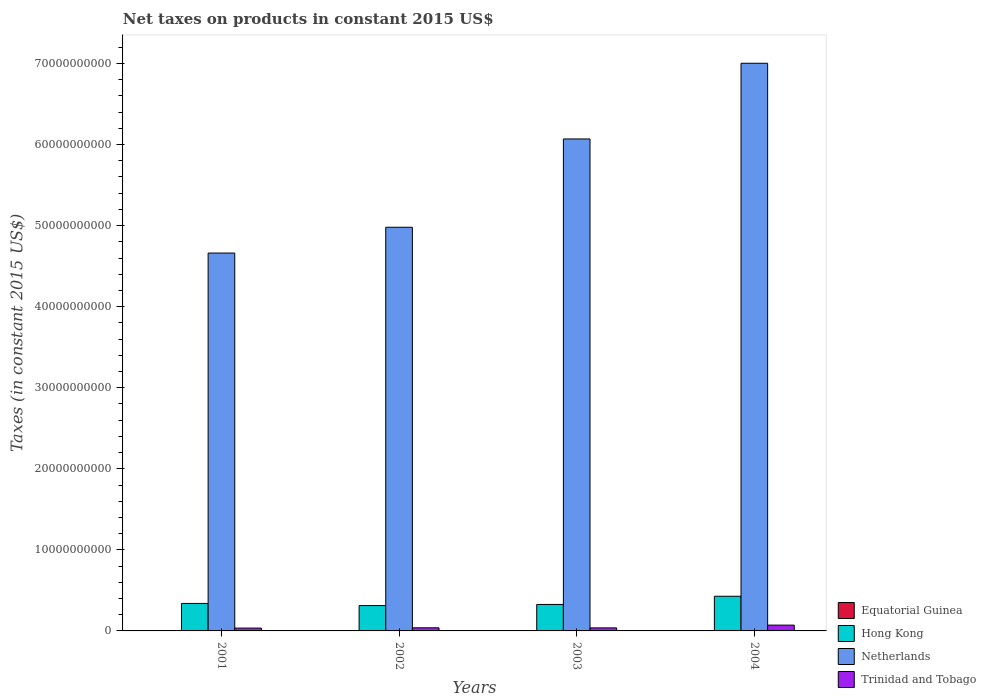How many bars are there on the 3rd tick from the left?
Your answer should be very brief. 4. How many bars are there on the 3rd tick from the right?
Your answer should be very brief. 4. What is the net taxes on products in Hong Kong in 2004?
Keep it short and to the point. 4.28e+09. Across all years, what is the maximum net taxes on products in Equatorial Guinea?
Make the answer very short. 4.28e+07. Across all years, what is the minimum net taxes on products in Equatorial Guinea?
Your answer should be compact. 1.68e+07. In which year was the net taxes on products in Equatorial Guinea maximum?
Your response must be concise. 2004. What is the total net taxes on products in Equatorial Guinea in the graph?
Provide a short and direct response. 1.14e+08. What is the difference between the net taxes on products in Netherlands in 2001 and that in 2002?
Give a very brief answer. -3.18e+09. What is the difference between the net taxes on products in Trinidad and Tobago in 2003 and the net taxes on products in Equatorial Guinea in 2004?
Offer a very short reply. 3.33e+08. What is the average net taxes on products in Hong Kong per year?
Provide a short and direct response. 3.51e+09. In the year 2004, what is the difference between the net taxes on products in Hong Kong and net taxes on products in Equatorial Guinea?
Provide a succinct answer. 4.23e+09. In how many years, is the net taxes on products in Netherlands greater than 16000000000 US$?
Offer a very short reply. 4. What is the ratio of the net taxes on products in Trinidad and Tobago in 2002 to that in 2004?
Give a very brief answer. 0.54. What is the difference between the highest and the second highest net taxes on products in Hong Kong?
Your response must be concise. 8.86e+08. What is the difference between the highest and the lowest net taxes on products in Hong Kong?
Offer a very short reply. 1.15e+09. Is it the case that in every year, the sum of the net taxes on products in Hong Kong and net taxes on products in Equatorial Guinea is greater than the sum of net taxes on products in Trinidad and Tobago and net taxes on products in Netherlands?
Keep it short and to the point. Yes. What does the 2nd bar from the left in 2004 represents?
Your answer should be very brief. Hong Kong. What does the 2nd bar from the right in 2004 represents?
Give a very brief answer. Netherlands. How many bars are there?
Keep it short and to the point. 16. What is the difference between two consecutive major ticks on the Y-axis?
Your answer should be very brief. 1.00e+1. Are the values on the major ticks of Y-axis written in scientific E-notation?
Keep it short and to the point. No. Does the graph contain grids?
Offer a very short reply. No. Where does the legend appear in the graph?
Provide a succinct answer. Bottom right. What is the title of the graph?
Your response must be concise. Net taxes on products in constant 2015 US$. Does "Libya" appear as one of the legend labels in the graph?
Give a very brief answer. No. What is the label or title of the X-axis?
Offer a terse response. Years. What is the label or title of the Y-axis?
Provide a succinct answer. Taxes (in constant 2015 US$). What is the Taxes (in constant 2015 US$) in Equatorial Guinea in 2001?
Offer a terse response. 1.68e+07. What is the Taxes (in constant 2015 US$) of Hong Kong in 2001?
Provide a short and direct response. 3.39e+09. What is the Taxes (in constant 2015 US$) in Netherlands in 2001?
Your answer should be compact. 4.66e+1. What is the Taxes (in constant 2015 US$) of Trinidad and Tobago in 2001?
Ensure brevity in your answer.  3.50e+08. What is the Taxes (in constant 2015 US$) of Equatorial Guinea in 2002?
Offer a very short reply. 2.04e+07. What is the Taxes (in constant 2015 US$) of Hong Kong in 2002?
Offer a very short reply. 3.13e+09. What is the Taxes (in constant 2015 US$) of Netherlands in 2002?
Ensure brevity in your answer.  4.98e+1. What is the Taxes (in constant 2015 US$) of Trinidad and Tobago in 2002?
Your response must be concise. 3.84e+08. What is the Taxes (in constant 2015 US$) of Equatorial Guinea in 2003?
Offer a terse response. 3.39e+07. What is the Taxes (in constant 2015 US$) of Hong Kong in 2003?
Your answer should be very brief. 3.27e+09. What is the Taxes (in constant 2015 US$) of Netherlands in 2003?
Ensure brevity in your answer.  6.07e+1. What is the Taxes (in constant 2015 US$) in Trinidad and Tobago in 2003?
Make the answer very short. 3.76e+08. What is the Taxes (in constant 2015 US$) in Equatorial Guinea in 2004?
Provide a succinct answer. 4.28e+07. What is the Taxes (in constant 2015 US$) of Hong Kong in 2004?
Keep it short and to the point. 4.28e+09. What is the Taxes (in constant 2015 US$) of Netherlands in 2004?
Your response must be concise. 7.00e+1. What is the Taxes (in constant 2015 US$) in Trinidad and Tobago in 2004?
Ensure brevity in your answer.  7.15e+08. Across all years, what is the maximum Taxes (in constant 2015 US$) of Equatorial Guinea?
Offer a very short reply. 4.28e+07. Across all years, what is the maximum Taxes (in constant 2015 US$) in Hong Kong?
Provide a succinct answer. 4.28e+09. Across all years, what is the maximum Taxes (in constant 2015 US$) in Netherlands?
Keep it short and to the point. 7.00e+1. Across all years, what is the maximum Taxes (in constant 2015 US$) in Trinidad and Tobago?
Your response must be concise. 7.15e+08. Across all years, what is the minimum Taxes (in constant 2015 US$) in Equatorial Guinea?
Keep it short and to the point. 1.68e+07. Across all years, what is the minimum Taxes (in constant 2015 US$) of Hong Kong?
Your answer should be very brief. 3.13e+09. Across all years, what is the minimum Taxes (in constant 2015 US$) in Netherlands?
Provide a succinct answer. 4.66e+1. Across all years, what is the minimum Taxes (in constant 2015 US$) in Trinidad and Tobago?
Your answer should be compact. 3.50e+08. What is the total Taxes (in constant 2015 US$) of Equatorial Guinea in the graph?
Provide a succinct answer. 1.14e+08. What is the total Taxes (in constant 2015 US$) of Hong Kong in the graph?
Offer a terse response. 1.41e+1. What is the total Taxes (in constant 2015 US$) of Netherlands in the graph?
Your answer should be very brief. 2.27e+11. What is the total Taxes (in constant 2015 US$) of Trinidad and Tobago in the graph?
Provide a short and direct response. 1.82e+09. What is the difference between the Taxes (in constant 2015 US$) of Equatorial Guinea in 2001 and that in 2002?
Your response must be concise. -3.60e+06. What is the difference between the Taxes (in constant 2015 US$) of Hong Kong in 2001 and that in 2002?
Offer a terse response. 2.60e+08. What is the difference between the Taxes (in constant 2015 US$) in Netherlands in 2001 and that in 2002?
Provide a succinct answer. -3.18e+09. What is the difference between the Taxes (in constant 2015 US$) of Trinidad and Tobago in 2001 and that in 2002?
Your answer should be very brief. -3.47e+07. What is the difference between the Taxes (in constant 2015 US$) of Equatorial Guinea in 2001 and that in 2003?
Keep it short and to the point. -1.71e+07. What is the difference between the Taxes (in constant 2015 US$) of Hong Kong in 2001 and that in 2003?
Keep it short and to the point. 1.24e+08. What is the difference between the Taxes (in constant 2015 US$) in Netherlands in 2001 and that in 2003?
Your answer should be very brief. -1.41e+1. What is the difference between the Taxes (in constant 2015 US$) of Trinidad and Tobago in 2001 and that in 2003?
Offer a very short reply. -2.60e+07. What is the difference between the Taxes (in constant 2015 US$) of Equatorial Guinea in 2001 and that in 2004?
Keep it short and to the point. -2.60e+07. What is the difference between the Taxes (in constant 2015 US$) in Hong Kong in 2001 and that in 2004?
Make the answer very short. -8.86e+08. What is the difference between the Taxes (in constant 2015 US$) of Netherlands in 2001 and that in 2004?
Your answer should be compact. -2.34e+1. What is the difference between the Taxes (in constant 2015 US$) in Trinidad and Tobago in 2001 and that in 2004?
Provide a short and direct response. -3.66e+08. What is the difference between the Taxes (in constant 2015 US$) of Equatorial Guinea in 2002 and that in 2003?
Your answer should be very brief. -1.35e+07. What is the difference between the Taxes (in constant 2015 US$) of Hong Kong in 2002 and that in 2003?
Provide a succinct answer. -1.36e+08. What is the difference between the Taxes (in constant 2015 US$) of Netherlands in 2002 and that in 2003?
Make the answer very short. -1.09e+1. What is the difference between the Taxes (in constant 2015 US$) in Trinidad and Tobago in 2002 and that in 2003?
Your answer should be very brief. 8.65e+06. What is the difference between the Taxes (in constant 2015 US$) of Equatorial Guinea in 2002 and that in 2004?
Offer a very short reply. -2.24e+07. What is the difference between the Taxes (in constant 2015 US$) of Hong Kong in 2002 and that in 2004?
Your answer should be compact. -1.15e+09. What is the difference between the Taxes (in constant 2015 US$) of Netherlands in 2002 and that in 2004?
Keep it short and to the point. -2.02e+1. What is the difference between the Taxes (in constant 2015 US$) of Trinidad and Tobago in 2002 and that in 2004?
Provide a succinct answer. -3.31e+08. What is the difference between the Taxes (in constant 2015 US$) in Equatorial Guinea in 2003 and that in 2004?
Offer a terse response. -8.84e+06. What is the difference between the Taxes (in constant 2015 US$) of Hong Kong in 2003 and that in 2004?
Your answer should be very brief. -1.01e+09. What is the difference between the Taxes (in constant 2015 US$) of Netherlands in 2003 and that in 2004?
Make the answer very short. -9.34e+09. What is the difference between the Taxes (in constant 2015 US$) in Trinidad and Tobago in 2003 and that in 2004?
Make the answer very short. -3.40e+08. What is the difference between the Taxes (in constant 2015 US$) of Equatorial Guinea in 2001 and the Taxes (in constant 2015 US$) of Hong Kong in 2002?
Keep it short and to the point. -3.11e+09. What is the difference between the Taxes (in constant 2015 US$) of Equatorial Guinea in 2001 and the Taxes (in constant 2015 US$) of Netherlands in 2002?
Offer a terse response. -4.98e+1. What is the difference between the Taxes (in constant 2015 US$) in Equatorial Guinea in 2001 and the Taxes (in constant 2015 US$) in Trinidad and Tobago in 2002?
Your answer should be compact. -3.67e+08. What is the difference between the Taxes (in constant 2015 US$) of Hong Kong in 2001 and the Taxes (in constant 2015 US$) of Netherlands in 2002?
Give a very brief answer. -4.64e+1. What is the difference between the Taxes (in constant 2015 US$) in Hong Kong in 2001 and the Taxes (in constant 2015 US$) in Trinidad and Tobago in 2002?
Give a very brief answer. 3.01e+09. What is the difference between the Taxes (in constant 2015 US$) in Netherlands in 2001 and the Taxes (in constant 2015 US$) in Trinidad and Tobago in 2002?
Your answer should be very brief. 4.62e+1. What is the difference between the Taxes (in constant 2015 US$) of Equatorial Guinea in 2001 and the Taxes (in constant 2015 US$) of Hong Kong in 2003?
Offer a terse response. -3.25e+09. What is the difference between the Taxes (in constant 2015 US$) of Equatorial Guinea in 2001 and the Taxes (in constant 2015 US$) of Netherlands in 2003?
Provide a succinct answer. -6.07e+1. What is the difference between the Taxes (in constant 2015 US$) of Equatorial Guinea in 2001 and the Taxes (in constant 2015 US$) of Trinidad and Tobago in 2003?
Your answer should be very brief. -3.59e+08. What is the difference between the Taxes (in constant 2015 US$) of Hong Kong in 2001 and the Taxes (in constant 2015 US$) of Netherlands in 2003?
Provide a short and direct response. -5.73e+1. What is the difference between the Taxes (in constant 2015 US$) in Hong Kong in 2001 and the Taxes (in constant 2015 US$) in Trinidad and Tobago in 2003?
Ensure brevity in your answer.  3.01e+09. What is the difference between the Taxes (in constant 2015 US$) of Netherlands in 2001 and the Taxes (in constant 2015 US$) of Trinidad and Tobago in 2003?
Your answer should be compact. 4.62e+1. What is the difference between the Taxes (in constant 2015 US$) of Equatorial Guinea in 2001 and the Taxes (in constant 2015 US$) of Hong Kong in 2004?
Your answer should be very brief. -4.26e+09. What is the difference between the Taxes (in constant 2015 US$) of Equatorial Guinea in 2001 and the Taxes (in constant 2015 US$) of Netherlands in 2004?
Make the answer very short. -7.00e+1. What is the difference between the Taxes (in constant 2015 US$) in Equatorial Guinea in 2001 and the Taxes (in constant 2015 US$) in Trinidad and Tobago in 2004?
Your answer should be very brief. -6.98e+08. What is the difference between the Taxes (in constant 2015 US$) in Hong Kong in 2001 and the Taxes (in constant 2015 US$) in Netherlands in 2004?
Your answer should be very brief. -6.66e+1. What is the difference between the Taxes (in constant 2015 US$) in Hong Kong in 2001 and the Taxes (in constant 2015 US$) in Trinidad and Tobago in 2004?
Provide a succinct answer. 2.67e+09. What is the difference between the Taxes (in constant 2015 US$) in Netherlands in 2001 and the Taxes (in constant 2015 US$) in Trinidad and Tobago in 2004?
Your answer should be very brief. 4.59e+1. What is the difference between the Taxes (in constant 2015 US$) in Equatorial Guinea in 2002 and the Taxes (in constant 2015 US$) in Hong Kong in 2003?
Provide a succinct answer. -3.25e+09. What is the difference between the Taxes (in constant 2015 US$) in Equatorial Guinea in 2002 and the Taxes (in constant 2015 US$) in Netherlands in 2003?
Your response must be concise. -6.07e+1. What is the difference between the Taxes (in constant 2015 US$) in Equatorial Guinea in 2002 and the Taxes (in constant 2015 US$) in Trinidad and Tobago in 2003?
Your answer should be very brief. -3.55e+08. What is the difference between the Taxes (in constant 2015 US$) of Hong Kong in 2002 and the Taxes (in constant 2015 US$) of Netherlands in 2003?
Keep it short and to the point. -5.76e+1. What is the difference between the Taxes (in constant 2015 US$) in Hong Kong in 2002 and the Taxes (in constant 2015 US$) in Trinidad and Tobago in 2003?
Give a very brief answer. 2.75e+09. What is the difference between the Taxes (in constant 2015 US$) in Netherlands in 2002 and the Taxes (in constant 2015 US$) in Trinidad and Tobago in 2003?
Provide a succinct answer. 4.94e+1. What is the difference between the Taxes (in constant 2015 US$) in Equatorial Guinea in 2002 and the Taxes (in constant 2015 US$) in Hong Kong in 2004?
Provide a short and direct response. -4.25e+09. What is the difference between the Taxes (in constant 2015 US$) of Equatorial Guinea in 2002 and the Taxes (in constant 2015 US$) of Netherlands in 2004?
Give a very brief answer. -7.00e+1. What is the difference between the Taxes (in constant 2015 US$) of Equatorial Guinea in 2002 and the Taxes (in constant 2015 US$) of Trinidad and Tobago in 2004?
Your answer should be very brief. -6.95e+08. What is the difference between the Taxes (in constant 2015 US$) of Hong Kong in 2002 and the Taxes (in constant 2015 US$) of Netherlands in 2004?
Offer a very short reply. -6.69e+1. What is the difference between the Taxes (in constant 2015 US$) in Hong Kong in 2002 and the Taxes (in constant 2015 US$) in Trinidad and Tobago in 2004?
Offer a terse response. 2.41e+09. What is the difference between the Taxes (in constant 2015 US$) of Netherlands in 2002 and the Taxes (in constant 2015 US$) of Trinidad and Tobago in 2004?
Keep it short and to the point. 4.91e+1. What is the difference between the Taxes (in constant 2015 US$) of Equatorial Guinea in 2003 and the Taxes (in constant 2015 US$) of Hong Kong in 2004?
Make the answer very short. -4.24e+09. What is the difference between the Taxes (in constant 2015 US$) of Equatorial Guinea in 2003 and the Taxes (in constant 2015 US$) of Netherlands in 2004?
Ensure brevity in your answer.  -7.00e+1. What is the difference between the Taxes (in constant 2015 US$) of Equatorial Guinea in 2003 and the Taxes (in constant 2015 US$) of Trinidad and Tobago in 2004?
Offer a very short reply. -6.81e+08. What is the difference between the Taxes (in constant 2015 US$) in Hong Kong in 2003 and the Taxes (in constant 2015 US$) in Netherlands in 2004?
Make the answer very short. -6.68e+1. What is the difference between the Taxes (in constant 2015 US$) of Hong Kong in 2003 and the Taxes (in constant 2015 US$) of Trinidad and Tobago in 2004?
Give a very brief answer. 2.55e+09. What is the difference between the Taxes (in constant 2015 US$) in Netherlands in 2003 and the Taxes (in constant 2015 US$) in Trinidad and Tobago in 2004?
Give a very brief answer. 6.00e+1. What is the average Taxes (in constant 2015 US$) in Equatorial Guinea per year?
Keep it short and to the point. 2.85e+07. What is the average Taxes (in constant 2015 US$) of Hong Kong per year?
Your response must be concise. 3.51e+09. What is the average Taxes (in constant 2015 US$) in Netherlands per year?
Make the answer very short. 5.68e+1. What is the average Taxes (in constant 2015 US$) in Trinidad and Tobago per year?
Your answer should be very brief. 4.56e+08. In the year 2001, what is the difference between the Taxes (in constant 2015 US$) in Equatorial Guinea and Taxes (in constant 2015 US$) in Hong Kong?
Give a very brief answer. -3.37e+09. In the year 2001, what is the difference between the Taxes (in constant 2015 US$) in Equatorial Guinea and Taxes (in constant 2015 US$) in Netherlands?
Make the answer very short. -4.66e+1. In the year 2001, what is the difference between the Taxes (in constant 2015 US$) in Equatorial Guinea and Taxes (in constant 2015 US$) in Trinidad and Tobago?
Make the answer very short. -3.33e+08. In the year 2001, what is the difference between the Taxes (in constant 2015 US$) of Hong Kong and Taxes (in constant 2015 US$) of Netherlands?
Offer a terse response. -4.32e+1. In the year 2001, what is the difference between the Taxes (in constant 2015 US$) in Hong Kong and Taxes (in constant 2015 US$) in Trinidad and Tobago?
Your answer should be very brief. 3.04e+09. In the year 2001, what is the difference between the Taxes (in constant 2015 US$) of Netherlands and Taxes (in constant 2015 US$) of Trinidad and Tobago?
Keep it short and to the point. 4.63e+1. In the year 2002, what is the difference between the Taxes (in constant 2015 US$) in Equatorial Guinea and Taxes (in constant 2015 US$) in Hong Kong?
Provide a succinct answer. -3.11e+09. In the year 2002, what is the difference between the Taxes (in constant 2015 US$) in Equatorial Guinea and Taxes (in constant 2015 US$) in Netherlands?
Your response must be concise. -4.98e+1. In the year 2002, what is the difference between the Taxes (in constant 2015 US$) of Equatorial Guinea and Taxes (in constant 2015 US$) of Trinidad and Tobago?
Keep it short and to the point. -3.64e+08. In the year 2002, what is the difference between the Taxes (in constant 2015 US$) of Hong Kong and Taxes (in constant 2015 US$) of Netherlands?
Your answer should be very brief. -4.67e+1. In the year 2002, what is the difference between the Taxes (in constant 2015 US$) of Hong Kong and Taxes (in constant 2015 US$) of Trinidad and Tobago?
Offer a very short reply. 2.75e+09. In the year 2002, what is the difference between the Taxes (in constant 2015 US$) in Netherlands and Taxes (in constant 2015 US$) in Trinidad and Tobago?
Your response must be concise. 4.94e+1. In the year 2003, what is the difference between the Taxes (in constant 2015 US$) in Equatorial Guinea and Taxes (in constant 2015 US$) in Hong Kong?
Make the answer very short. -3.23e+09. In the year 2003, what is the difference between the Taxes (in constant 2015 US$) of Equatorial Guinea and Taxes (in constant 2015 US$) of Netherlands?
Keep it short and to the point. -6.07e+1. In the year 2003, what is the difference between the Taxes (in constant 2015 US$) of Equatorial Guinea and Taxes (in constant 2015 US$) of Trinidad and Tobago?
Keep it short and to the point. -3.42e+08. In the year 2003, what is the difference between the Taxes (in constant 2015 US$) of Hong Kong and Taxes (in constant 2015 US$) of Netherlands?
Ensure brevity in your answer.  -5.74e+1. In the year 2003, what is the difference between the Taxes (in constant 2015 US$) of Hong Kong and Taxes (in constant 2015 US$) of Trinidad and Tobago?
Keep it short and to the point. 2.89e+09. In the year 2003, what is the difference between the Taxes (in constant 2015 US$) in Netherlands and Taxes (in constant 2015 US$) in Trinidad and Tobago?
Offer a very short reply. 6.03e+1. In the year 2004, what is the difference between the Taxes (in constant 2015 US$) in Equatorial Guinea and Taxes (in constant 2015 US$) in Hong Kong?
Keep it short and to the point. -4.23e+09. In the year 2004, what is the difference between the Taxes (in constant 2015 US$) in Equatorial Guinea and Taxes (in constant 2015 US$) in Netherlands?
Provide a succinct answer. -7.00e+1. In the year 2004, what is the difference between the Taxes (in constant 2015 US$) in Equatorial Guinea and Taxes (in constant 2015 US$) in Trinidad and Tobago?
Offer a very short reply. -6.73e+08. In the year 2004, what is the difference between the Taxes (in constant 2015 US$) in Hong Kong and Taxes (in constant 2015 US$) in Netherlands?
Keep it short and to the point. -6.58e+1. In the year 2004, what is the difference between the Taxes (in constant 2015 US$) in Hong Kong and Taxes (in constant 2015 US$) in Trinidad and Tobago?
Keep it short and to the point. 3.56e+09. In the year 2004, what is the difference between the Taxes (in constant 2015 US$) in Netherlands and Taxes (in constant 2015 US$) in Trinidad and Tobago?
Provide a short and direct response. 6.93e+1. What is the ratio of the Taxes (in constant 2015 US$) of Equatorial Guinea in 2001 to that in 2002?
Give a very brief answer. 0.82. What is the ratio of the Taxes (in constant 2015 US$) in Hong Kong in 2001 to that in 2002?
Provide a short and direct response. 1.08. What is the ratio of the Taxes (in constant 2015 US$) of Netherlands in 2001 to that in 2002?
Keep it short and to the point. 0.94. What is the ratio of the Taxes (in constant 2015 US$) of Trinidad and Tobago in 2001 to that in 2002?
Give a very brief answer. 0.91. What is the ratio of the Taxes (in constant 2015 US$) in Equatorial Guinea in 2001 to that in 2003?
Offer a terse response. 0.5. What is the ratio of the Taxes (in constant 2015 US$) of Hong Kong in 2001 to that in 2003?
Provide a succinct answer. 1.04. What is the ratio of the Taxes (in constant 2015 US$) in Netherlands in 2001 to that in 2003?
Provide a succinct answer. 0.77. What is the ratio of the Taxes (in constant 2015 US$) of Trinidad and Tobago in 2001 to that in 2003?
Make the answer very short. 0.93. What is the ratio of the Taxes (in constant 2015 US$) of Equatorial Guinea in 2001 to that in 2004?
Keep it short and to the point. 0.39. What is the ratio of the Taxes (in constant 2015 US$) in Hong Kong in 2001 to that in 2004?
Keep it short and to the point. 0.79. What is the ratio of the Taxes (in constant 2015 US$) in Netherlands in 2001 to that in 2004?
Offer a very short reply. 0.67. What is the ratio of the Taxes (in constant 2015 US$) of Trinidad and Tobago in 2001 to that in 2004?
Keep it short and to the point. 0.49. What is the ratio of the Taxes (in constant 2015 US$) of Equatorial Guinea in 2002 to that in 2003?
Keep it short and to the point. 0.6. What is the ratio of the Taxes (in constant 2015 US$) in Netherlands in 2002 to that in 2003?
Provide a succinct answer. 0.82. What is the ratio of the Taxes (in constant 2015 US$) of Trinidad and Tobago in 2002 to that in 2003?
Make the answer very short. 1.02. What is the ratio of the Taxes (in constant 2015 US$) in Equatorial Guinea in 2002 to that in 2004?
Your answer should be very brief. 0.48. What is the ratio of the Taxes (in constant 2015 US$) in Hong Kong in 2002 to that in 2004?
Your answer should be very brief. 0.73. What is the ratio of the Taxes (in constant 2015 US$) in Netherlands in 2002 to that in 2004?
Provide a succinct answer. 0.71. What is the ratio of the Taxes (in constant 2015 US$) in Trinidad and Tobago in 2002 to that in 2004?
Offer a very short reply. 0.54. What is the ratio of the Taxes (in constant 2015 US$) of Equatorial Guinea in 2003 to that in 2004?
Your response must be concise. 0.79. What is the ratio of the Taxes (in constant 2015 US$) of Hong Kong in 2003 to that in 2004?
Offer a very short reply. 0.76. What is the ratio of the Taxes (in constant 2015 US$) in Netherlands in 2003 to that in 2004?
Your answer should be compact. 0.87. What is the ratio of the Taxes (in constant 2015 US$) in Trinidad and Tobago in 2003 to that in 2004?
Your response must be concise. 0.53. What is the difference between the highest and the second highest Taxes (in constant 2015 US$) of Equatorial Guinea?
Give a very brief answer. 8.84e+06. What is the difference between the highest and the second highest Taxes (in constant 2015 US$) in Hong Kong?
Provide a succinct answer. 8.86e+08. What is the difference between the highest and the second highest Taxes (in constant 2015 US$) of Netherlands?
Give a very brief answer. 9.34e+09. What is the difference between the highest and the second highest Taxes (in constant 2015 US$) of Trinidad and Tobago?
Offer a terse response. 3.31e+08. What is the difference between the highest and the lowest Taxes (in constant 2015 US$) in Equatorial Guinea?
Ensure brevity in your answer.  2.60e+07. What is the difference between the highest and the lowest Taxes (in constant 2015 US$) of Hong Kong?
Your answer should be compact. 1.15e+09. What is the difference between the highest and the lowest Taxes (in constant 2015 US$) in Netherlands?
Offer a very short reply. 2.34e+1. What is the difference between the highest and the lowest Taxes (in constant 2015 US$) of Trinidad and Tobago?
Provide a short and direct response. 3.66e+08. 